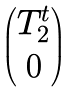Convert formula to latex. <formula><loc_0><loc_0><loc_500><loc_500>\begin{pmatrix} T ^ { t } _ { 2 } \\ 0 \end{pmatrix}</formula> 